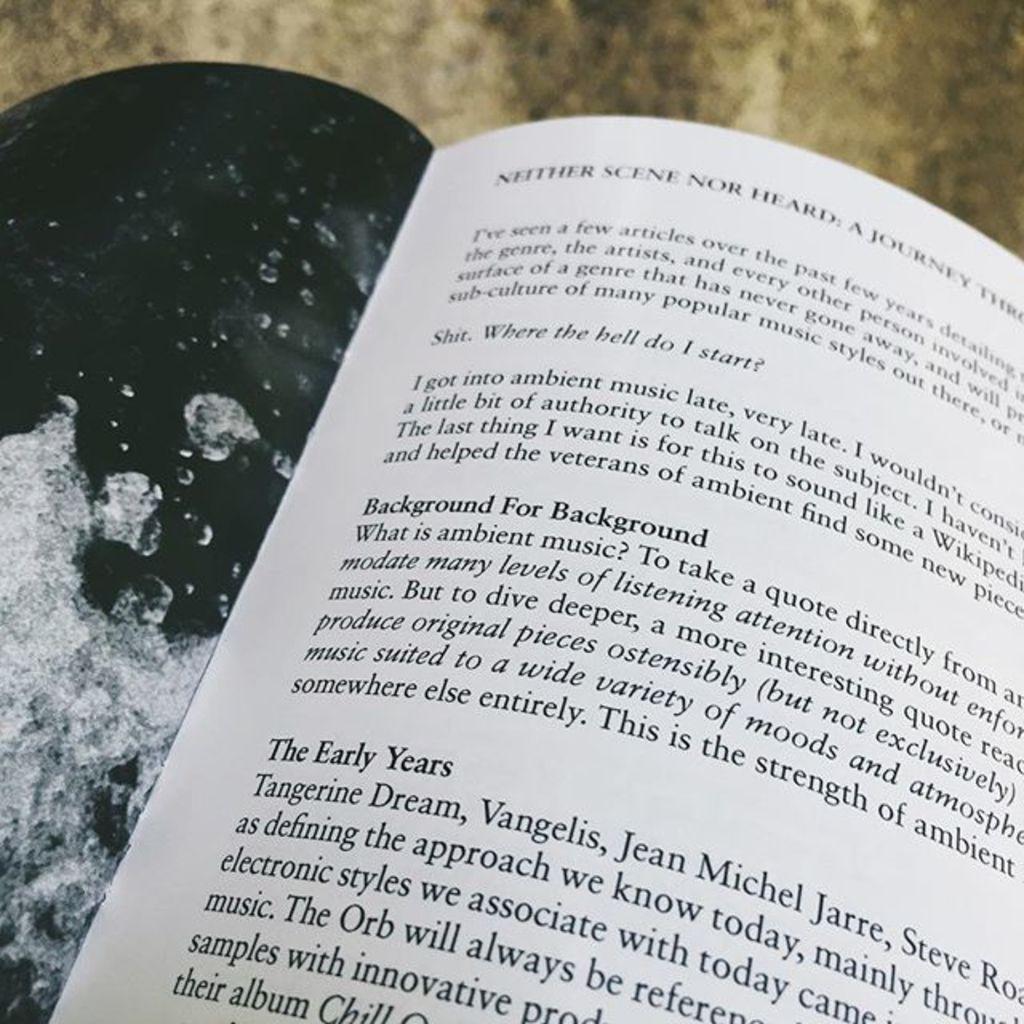What is the first band listed?
Make the answer very short. Tangerine dream. 